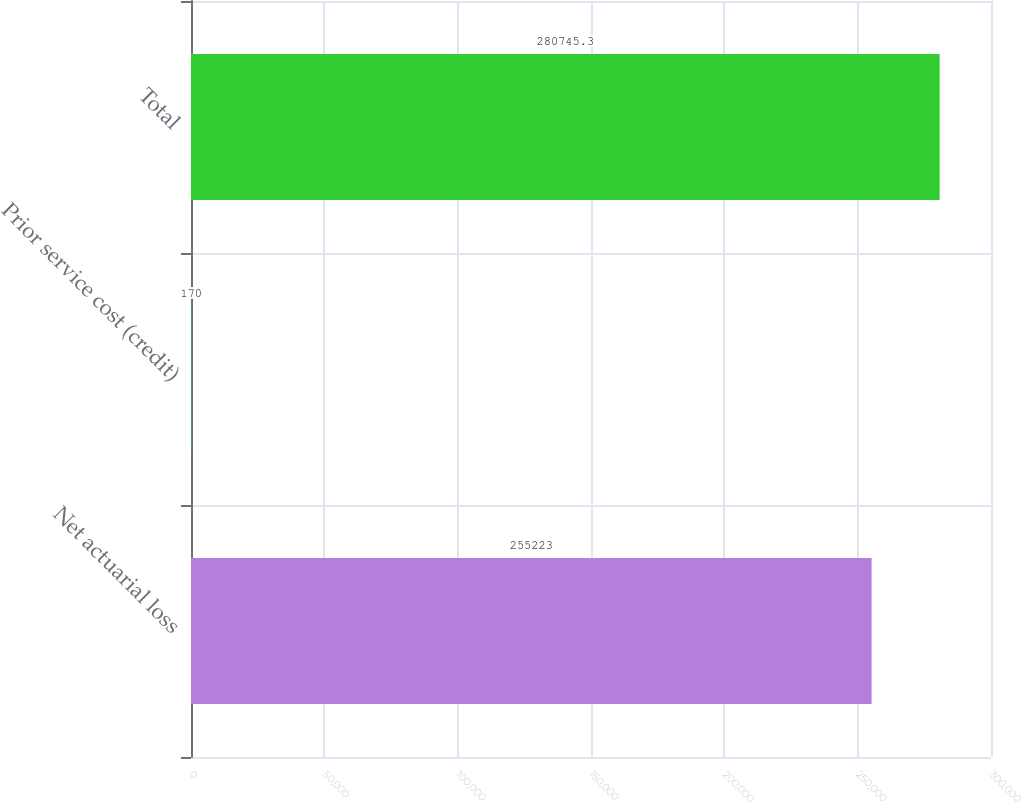Convert chart to OTSL. <chart><loc_0><loc_0><loc_500><loc_500><bar_chart><fcel>Net actuarial loss<fcel>Prior service cost (credit)<fcel>Total<nl><fcel>255223<fcel>170<fcel>280745<nl></chart> 